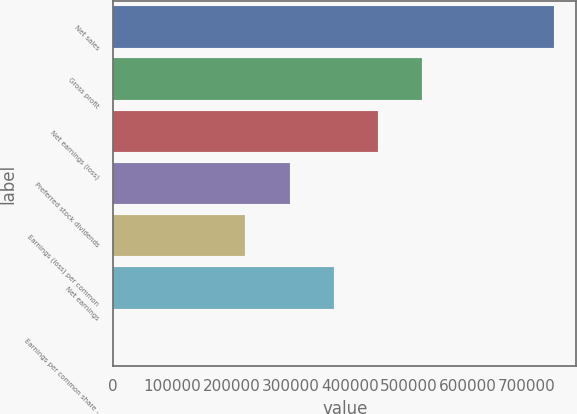Convert chart to OTSL. <chart><loc_0><loc_0><loc_500><loc_500><bar_chart><fcel>Net sales<fcel>Gross profit<fcel>Net earnings (loss)<fcel>Preferred stock dividends<fcel>Earnings (loss) per common<fcel>Net earnings<fcel>Earnings per common share -<nl><fcel>746087<fcel>522261<fcel>447652<fcel>298435<fcel>223826<fcel>373044<fcel>0.25<nl></chart> 